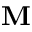<formula> <loc_0><loc_0><loc_500><loc_500>M</formula> 